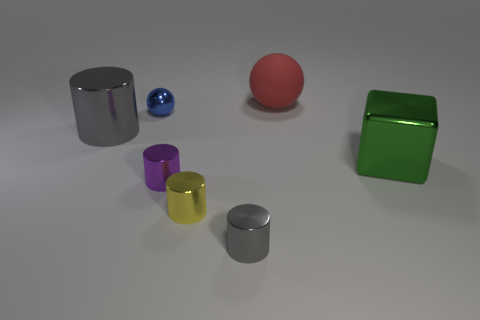Add 1 purple metallic cylinders. How many objects exist? 8 Subtract all cubes. How many objects are left? 6 Subtract 0 brown cylinders. How many objects are left? 7 Subtract all big blue spheres. Subtract all blue shiny objects. How many objects are left? 6 Add 2 tiny gray cylinders. How many tiny gray cylinders are left? 3 Add 4 yellow metal cylinders. How many yellow metal cylinders exist? 5 